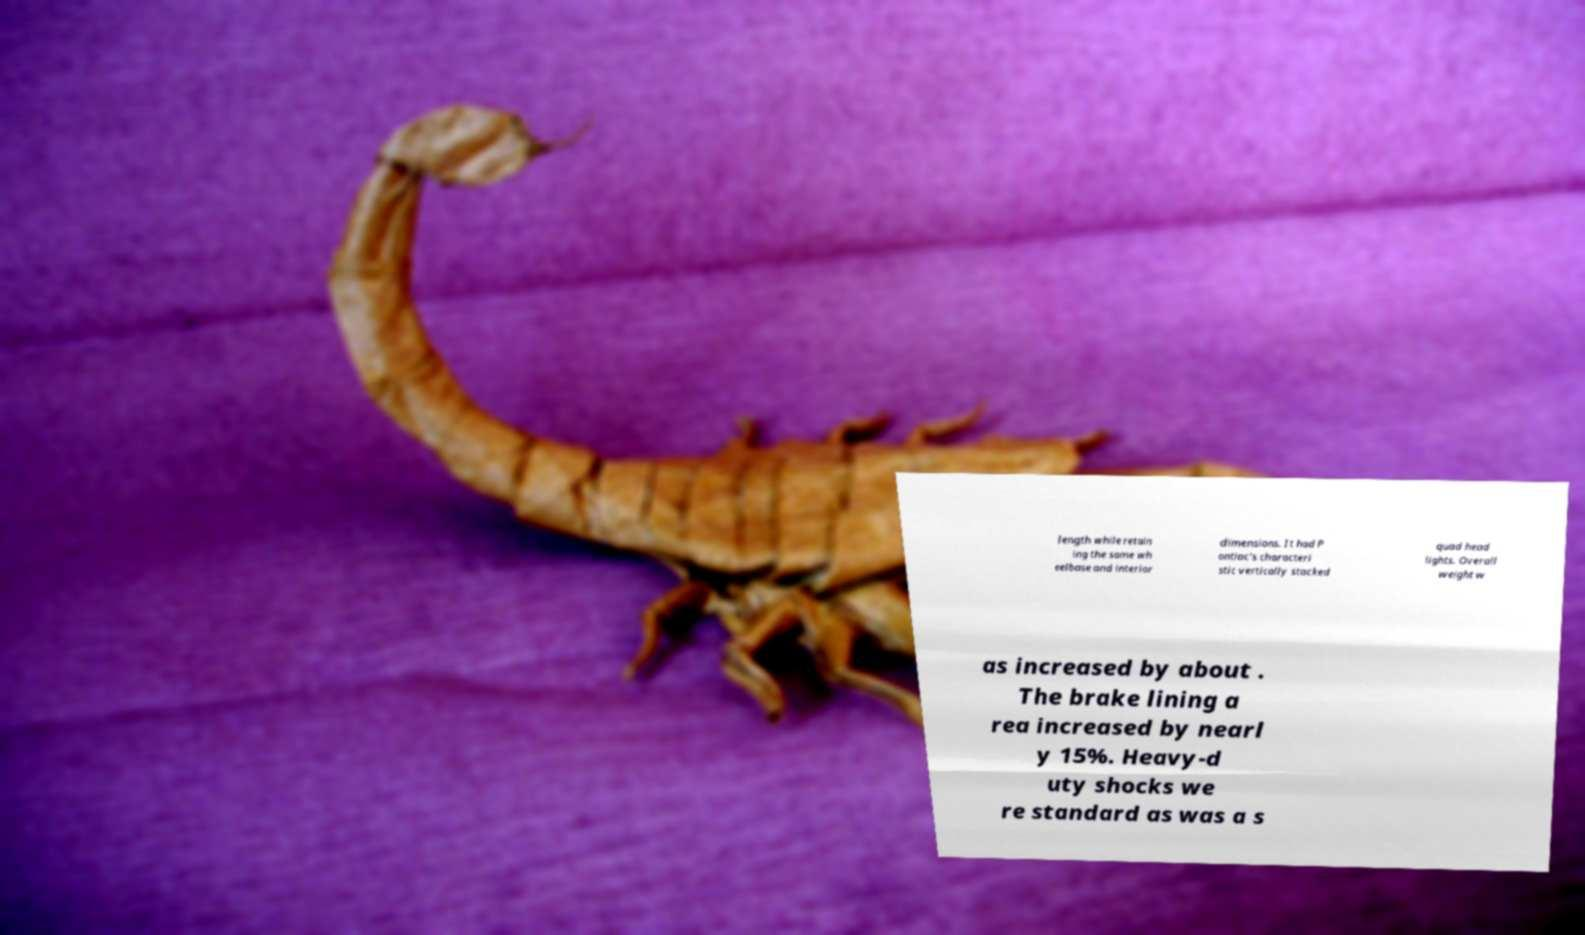Could you extract and type out the text from this image? length while retain ing the same wh eelbase and interior dimensions. It had P ontiac's characteri stic vertically stacked quad head lights. Overall weight w as increased by about . The brake lining a rea increased by nearl y 15%. Heavy-d uty shocks we re standard as was a s 